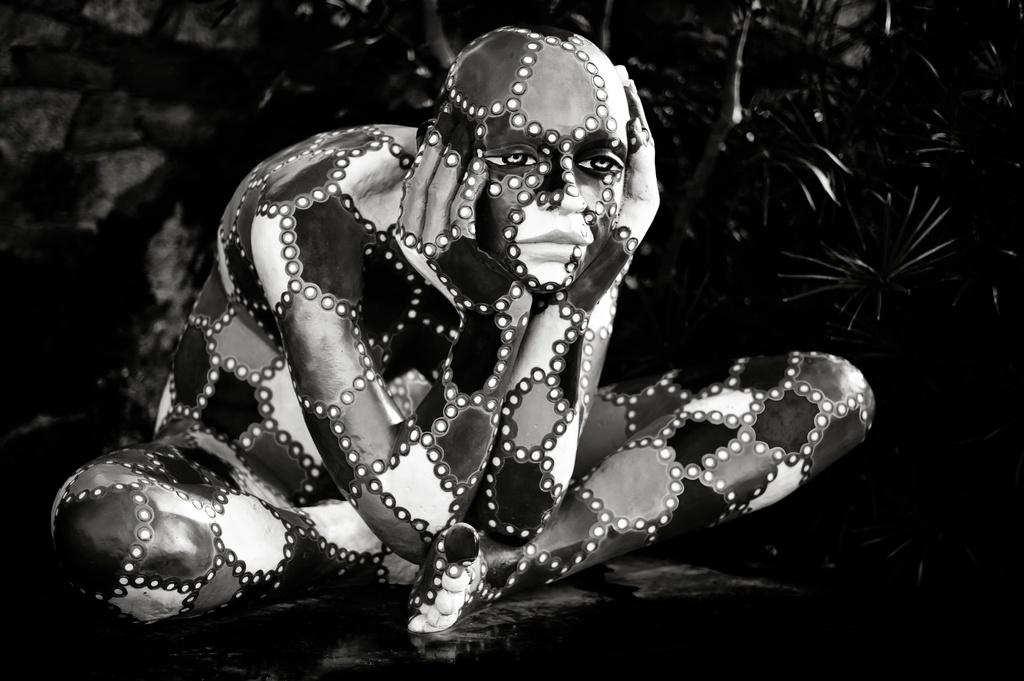What is the color scheme of the image? The image is monochrome. What can be seen in the image? There is a person sitting in the image. What color is the background of the image? The background of the image is black in color. What verse is the person reciting in the image? There is no verse being recited in the image, as it is a monochrome image of a person sitting with a black background. 